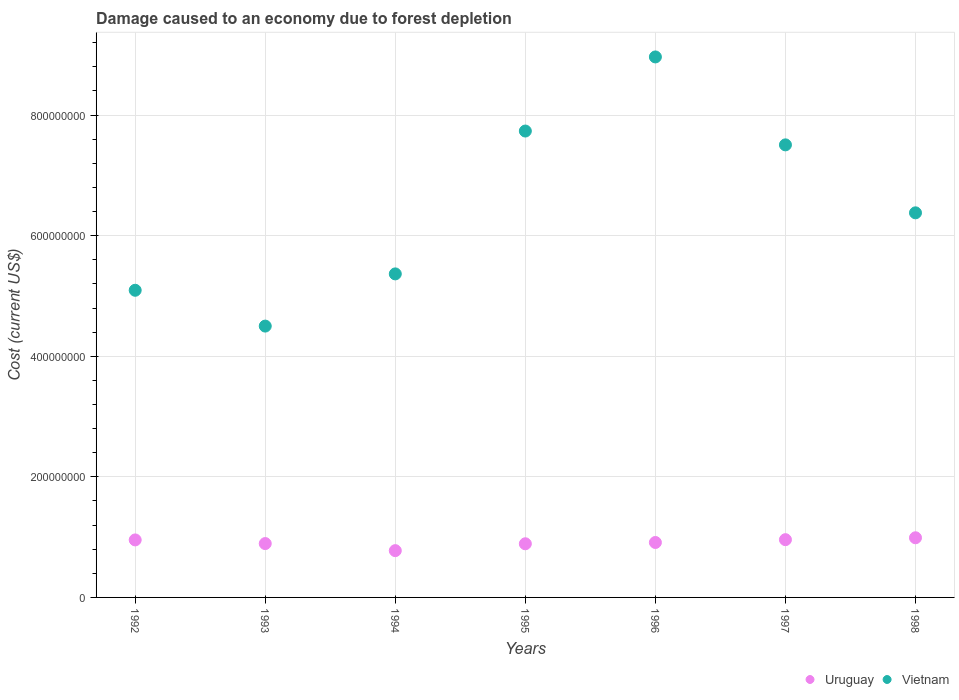How many different coloured dotlines are there?
Keep it short and to the point. 2. Is the number of dotlines equal to the number of legend labels?
Keep it short and to the point. Yes. What is the cost of damage caused due to forest depletion in Vietnam in 1996?
Give a very brief answer. 8.96e+08. Across all years, what is the maximum cost of damage caused due to forest depletion in Uruguay?
Give a very brief answer. 9.89e+07. Across all years, what is the minimum cost of damage caused due to forest depletion in Uruguay?
Your answer should be very brief. 7.76e+07. In which year was the cost of damage caused due to forest depletion in Vietnam maximum?
Ensure brevity in your answer.  1996. What is the total cost of damage caused due to forest depletion in Vietnam in the graph?
Offer a very short reply. 4.55e+09. What is the difference between the cost of damage caused due to forest depletion in Uruguay in 1993 and that in 1996?
Give a very brief answer. -1.80e+06. What is the difference between the cost of damage caused due to forest depletion in Vietnam in 1992 and the cost of damage caused due to forest depletion in Uruguay in 1995?
Give a very brief answer. 4.20e+08. What is the average cost of damage caused due to forest depletion in Vietnam per year?
Your answer should be very brief. 6.51e+08. In the year 1995, what is the difference between the cost of damage caused due to forest depletion in Uruguay and cost of damage caused due to forest depletion in Vietnam?
Provide a succinct answer. -6.85e+08. What is the ratio of the cost of damage caused due to forest depletion in Uruguay in 1992 to that in 1996?
Ensure brevity in your answer.  1.05. Is the cost of damage caused due to forest depletion in Vietnam in 1994 less than that in 1998?
Keep it short and to the point. Yes. Is the difference between the cost of damage caused due to forest depletion in Uruguay in 1993 and 1998 greater than the difference between the cost of damage caused due to forest depletion in Vietnam in 1993 and 1998?
Provide a succinct answer. Yes. What is the difference between the highest and the second highest cost of damage caused due to forest depletion in Vietnam?
Provide a succinct answer. 1.23e+08. What is the difference between the highest and the lowest cost of damage caused due to forest depletion in Uruguay?
Keep it short and to the point. 2.13e+07. Is the sum of the cost of damage caused due to forest depletion in Uruguay in 1995 and 1996 greater than the maximum cost of damage caused due to forest depletion in Vietnam across all years?
Make the answer very short. No. How many years are there in the graph?
Keep it short and to the point. 7. What is the difference between two consecutive major ticks on the Y-axis?
Offer a terse response. 2.00e+08. How are the legend labels stacked?
Your answer should be very brief. Horizontal. What is the title of the graph?
Your answer should be compact. Damage caused to an economy due to forest depletion. What is the label or title of the Y-axis?
Ensure brevity in your answer.  Cost (current US$). What is the Cost (current US$) of Uruguay in 1992?
Offer a very short reply. 9.54e+07. What is the Cost (current US$) in Vietnam in 1992?
Give a very brief answer. 5.09e+08. What is the Cost (current US$) of Uruguay in 1993?
Keep it short and to the point. 8.93e+07. What is the Cost (current US$) of Vietnam in 1993?
Your answer should be very brief. 4.50e+08. What is the Cost (current US$) in Uruguay in 1994?
Offer a very short reply. 7.76e+07. What is the Cost (current US$) in Vietnam in 1994?
Ensure brevity in your answer.  5.37e+08. What is the Cost (current US$) of Uruguay in 1995?
Offer a very short reply. 8.90e+07. What is the Cost (current US$) in Vietnam in 1995?
Provide a short and direct response. 7.74e+08. What is the Cost (current US$) in Uruguay in 1996?
Ensure brevity in your answer.  9.11e+07. What is the Cost (current US$) in Vietnam in 1996?
Ensure brevity in your answer.  8.96e+08. What is the Cost (current US$) of Uruguay in 1997?
Ensure brevity in your answer.  9.58e+07. What is the Cost (current US$) of Vietnam in 1997?
Ensure brevity in your answer.  7.51e+08. What is the Cost (current US$) of Uruguay in 1998?
Ensure brevity in your answer.  9.89e+07. What is the Cost (current US$) in Vietnam in 1998?
Make the answer very short. 6.38e+08. Across all years, what is the maximum Cost (current US$) of Uruguay?
Ensure brevity in your answer.  9.89e+07. Across all years, what is the maximum Cost (current US$) in Vietnam?
Provide a short and direct response. 8.96e+08. Across all years, what is the minimum Cost (current US$) in Uruguay?
Your answer should be very brief. 7.76e+07. Across all years, what is the minimum Cost (current US$) in Vietnam?
Your answer should be very brief. 4.50e+08. What is the total Cost (current US$) in Uruguay in the graph?
Give a very brief answer. 6.37e+08. What is the total Cost (current US$) in Vietnam in the graph?
Give a very brief answer. 4.55e+09. What is the difference between the Cost (current US$) of Uruguay in 1992 and that in 1993?
Provide a short and direct response. 6.05e+06. What is the difference between the Cost (current US$) in Vietnam in 1992 and that in 1993?
Offer a very short reply. 5.94e+07. What is the difference between the Cost (current US$) in Uruguay in 1992 and that in 1994?
Make the answer very short. 1.78e+07. What is the difference between the Cost (current US$) in Vietnam in 1992 and that in 1994?
Make the answer very short. -2.72e+07. What is the difference between the Cost (current US$) in Uruguay in 1992 and that in 1995?
Ensure brevity in your answer.  6.38e+06. What is the difference between the Cost (current US$) in Vietnam in 1992 and that in 1995?
Your answer should be very brief. -2.64e+08. What is the difference between the Cost (current US$) of Uruguay in 1992 and that in 1996?
Your answer should be very brief. 4.25e+06. What is the difference between the Cost (current US$) in Vietnam in 1992 and that in 1996?
Offer a very short reply. -3.87e+08. What is the difference between the Cost (current US$) of Uruguay in 1992 and that in 1997?
Provide a short and direct response. -4.16e+05. What is the difference between the Cost (current US$) of Vietnam in 1992 and that in 1997?
Make the answer very short. -2.41e+08. What is the difference between the Cost (current US$) of Uruguay in 1992 and that in 1998?
Provide a short and direct response. -3.57e+06. What is the difference between the Cost (current US$) in Vietnam in 1992 and that in 1998?
Your answer should be very brief. -1.28e+08. What is the difference between the Cost (current US$) of Uruguay in 1993 and that in 1994?
Provide a short and direct response. 1.17e+07. What is the difference between the Cost (current US$) of Vietnam in 1993 and that in 1994?
Ensure brevity in your answer.  -8.66e+07. What is the difference between the Cost (current US$) of Uruguay in 1993 and that in 1995?
Provide a succinct answer. 3.34e+05. What is the difference between the Cost (current US$) of Vietnam in 1993 and that in 1995?
Provide a short and direct response. -3.23e+08. What is the difference between the Cost (current US$) of Uruguay in 1993 and that in 1996?
Ensure brevity in your answer.  -1.80e+06. What is the difference between the Cost (current US$) of Vietnam in 1993 and that in 1996?
Your answer should be very brief. -4.46e+08. What is the difference between the Cost (current US$) of Uruguay in 1993 and that in 1997?
Provide a short and direct response. -6.47e+06. What is the difference between the Cost (current US$) of Vietnam in 1993 and that in 1997?
Offer a very short reply. -3.01e+08. What is the difference between the Cost (current US$) of Uruguay in 1993 and that in 1998?
Make the answer very short. -9.62e+06. What is the difference between the Cost (current US$) in Vietnam in 1993 and that in 1998?
Provide a short and direct response. -1.88e+08. What is the difference between the Cost (current US$) of Uruguay in 1994 and that in 1995?
Your response must be concise. -1.14e+07. What is the difference between the Cost (current US$) in Vietnam in 1994 and that in 1995?
Provide a short and direct response. -2.37e+08. What is the difference between the Cost (current US$) in Uruguay in 1994 and that in 1996?
Your answer should be compact. -1.35e+07. What is the difference between the Cost (current US$) in Vietnam in 1994 and that in 1996?
Offer a very short reply. -3.60e+08. What is the difference between the Cost (current US$) in Uruguay in 1994 and that in 1997?
Your response must be concise. -1.82e+07. What is the difference between the Cost (current US$) of Vietnam in 1994 and that in 1997?
Provide a succinct answer. -2.14e+08. What is the difference between the Cost (current US$) in Uruguay in 1994 and that in 1998?
Provide a short and direct response. -2.13e+07. What is the difference between the Cost (current US$) in Vietnam in 1994 and that in 1998?
Your answer should be compact. -1.01e+08. What is the difference between the Cost (current US$) in Uruguay in 1995 and that in 1996?
Your response must be concise. -2.14e+06. What is the difference between the Cost (current US$) in Vietnam in 1995 and that in 1996?
Keep it short and to the point. -1.23e+08. What is the difference between the Cost (current US$) of Uruguay in 1995 and that in 1997?
Your answer should be very brief. -6.80e+06. What is the difference between the Cost (current US$) in Vietnam in 1995 and that in 1997?
Your response must be concise. 2.29e+07. What is the difference between the Cost (current US$) of Uruguay in 1995 and that in 1998?
Provide a succinct answer. -9.95e+06. What is the difference between the Cost (current US$) of Vietnam in 1995 and that in 1998?
Ensure brevity in your answer.  1.36e+08. What is the difference between the Cost (current US$) in Uruguay in 1996 and that in 1997?
Make the answer very short. -4.66e+06. What is the difference between the Cost (current US$) in Vietnam in 1996 and that in 1997?
Your response must be concise. 1.46e+08. What is the difference between the Cost (current US$) of Uruguay in 1996 and that in 1998?
Your response must be concise. -7.82e+06. What is the difference between the Cost (current US$) in Vietnam in 1996 and that in 1998?
Your response must be concise. 2.59e+08. What is the difference between the Cost (current US$) in Uruguay in 1997 and that in 1998?
Your answer should be very brief. -3.15e+06. What is the difference between the Cost (current US$) in Vietnam in 1997 and that in 1998?
Your answer should be very brief. 1.13e+08. What is the difference between the Cost (current US$) in Uruguay in 1992 and the Cost (current US$) in Vietnam in 1993?
Offer a terse response. -3.55e+08. What is the difference between the Cost (current US$) of Uruguay in 1992 and the Cost (current US$) of Vietnam in 1994?
Ensure brevity in your answer.  -4.41e+08. What is the difference between the Cost (current US$) of Uruguay in 1992 and the Cost (current US$) of Vietnam in 1995?
Offer a very short reply. -6.78e+08. What is the difference between the Cost (current US$) in Uruguay in 1992 and the Cost (current US$) in Vietnam in 1996?
Give a very brief answer. -8.01e+08. What is the difference between the Cost (current US$) in Uruguay in 1992 and the Cost (current US$) in Vietnam in 1997?
Your response must be concise. -6.55e+08. What is the difference between the Cost (current US$) of Uruguay in 1992 and the Cost (current US$) of Vietnam in 1998?
Make the answer very short. -5.42e+08. What is the difference between the Cost (current US$) in Uruguay in 1993 and the Cost (current US$) in Vietnam in 1994?
Offer a terse response. -4.47e+08. What is the difference between the Cost (current US$) of Uruguay in 1993 and the Cost (current US$) of Vietnam in 1995?
Make the answer very short. -6.84e+08. What is the difference between the Cost (current US$) of Uruguay in 1993 and the Cost (current US$) of Vietnam in 1996?
Give a very brief answer. -8.07e+08. What is the difference between the Cost (current US$) of Uruguay in 1993 and the Cost (current US$) of Vietnam in 1997?
Provide a short and direct response. -6.61e+08. What is the difference between the Cost (current US$) of Uruguay in 1993 and the Cost (current US$) of Vietnam in 1998?
Your answer should be compact. -5.49e+08. What is the difference between the Cost (current US$) in Uruguay in 1994 and the Cost (current US$) in Vietnam in 1995?
Your response must be concise. -6.96e+08. What is the difference between the Cost (current US$) in Uruguay in 1994 and the Cost (current US$) in Vietnam in 1996?
Ensure brevity in your answer.  -8.19e+08. What is the difference between the Cost (current US$) of Uruguay in 1994 and the Cost (current US$) of Vietnam in 1997?
Keep it short and to the point. -6.73e+08. What is the difference between the Cost (current US$) in Uruguay in 1994 and the Cost (current US$) in Vietnam in 1998?
Keep it short and to the point. -5.60e+08. What is the difference between the Cost (current US$) of Uruguay in 1995 and the Cost (current US$) of Vietnam in 1996?
Your answer should be compact. -8.07e+08. What is the difference between the Cost (current US$) in Uruguay in 1995 and the Cost (current US$) in Vietnam in 1997?
Provide a short and direct response. -6.62e+08. What is the difference between the Cost (current US$) in Uruguay in 1995 and the Cost (current US$) in Vietnam in 1998?
Keep it short and to the point. -5.49e+08. What is the difference between the Cost (current US$) of Uruguay in 1996 and the Cost (current US$) of Vietnam in 1997?
Give a very brief answer. -6.59e+08. What is the difference between the Cost (current US$) in Uruguay in 1996 and the Cost (current US$) in Vietnam in 1998?
Provide a short and direct response. -5.47e+08. What is the difference between the Cost (current US$) of Uruguay in 1997 and the Cost (current US$) of Vietnam in 1998?
Make the answer very short. -5.42e+08. What is the average Cost (current US$) in Uruguay per year?
Offer a terse response. 9.10e+07. What is the average Cost (current US$) of Vietnam per year?
Your answer should be very brief. 6.51e+08. In the year 1992, what is the difference between the Cost (current US$) in Uruguay and Cost (current US$) in Vietnam?
Provide a succinct answer. -4.14e+08. In the year 1993, what is the difference between the Cost (current US$) of Uruguay and Cost (current US$) of Vietnam?
Keep it short and to the point. -3.61e+08. In the year 1994, what is the difference between the Cost (current US$) of Uruguay and Cost (current US$) of Vietnam?
Provide a short and direct response. -4.59e+08. In the year 1995, what is the difference between the Cost (current US$) of Uruguay and Cost (current US$) of Vietnam?
Your answer should be compact. -6.85e+08. In the year 1996, what is the difference between the Cost (current US$) in Uruguay and Cost (current US$) in Vietnam?
Provide a succinct answer. -8.05e+08. In the year 1997, what is the difference between the Cost (current US$) of Uruguay and Cost (current US$) of Vietnam?
Give a very brief answer. -6.55e+08. In the year 1998, what is the difference between the Cost (current US$) of Uruguay and Cost (current US$) of Vietnam?
Make the answer very short. -5.39e+08. What is the ratio of the Cost (current US$) of Uruguay in 1992 to that in 1993?
Keep it short and to the point. 1.07. What is the ratio of the Cost (current US$) of Vietnam in 1992 to that in 1993?
Offer a terse response. 1.13. What is the ratio of the Cost (current US$) of Uruguay in 1992 to that in 1994?
Your answer should be very brief. 1.23. What is the ratio of the Cost (current US$) of Vietnam in 1992 to that in 1994?
Make the answer very short. 0.95. What is the ratio of the Cost (current US$) of Uruguay in 1992 to that in 1995?
Provide a short and direct response. 1.07. What is the ratio of the Cost (current US$) of Vietnam in 1992 to that in 1995?
Ensure brevity in your answer.  0.66. What is the ratio of the Cost (current US$) of Uruguay in 1992 to that in 1996?
Your answer should be compact. 1.05. What is the ratio of the Cost (current US$) of Vietnam in 1992 to that in 1996?
Make the answer very short. 0.57. What is the ratio of the Cost (current US$) of Uruguay in 1992 to that in 1997?
Ensure brevity in your answer.  1. What is the ratio of the Cost (current US$) in Vietnam in 1992 to that in 1997?
Offer a very short reply. 0.68. What is the ratio of the Cost (current US$) in Uruguay in 1992 to that in 1998?
Offer a very short reply. 0.96. What is the ratio of the Cost (current US$) in Vietnam in 1992 to that in 1998?
Offer a terse response. 0.8. What is the ratio of the Cost (current US$) of Uruguay in 1993 to that in 1994?
Your response must be concise. 1.15. What is the ratio of the Cost (current US$) in Vietnam in 1993 to that in 1994?
Keep it short and to the point. 0.84. What is the ratio of the Cost (current US$) of Vietnam in 1993 to that in 1995?
Offer a very short reply. 0.58. What is the ratio of the Cost (current US$) of Uruguay in 1993 to that in 1996?
Give a very brief answer. 0.98. What is the ratio of the Cost (current US$) of Vietnam in 1993 to that in 1996?
Your response must be concise. 0.5. What is the ratio of the Cost (current US$) in Uruguay in 1993 to that in 1997?
Your answer should be compact. 0.93. What is the ratio of the Cost (current US$) of Vietnam in 1993 to that in 1997?
Make the answer very short. 0.6. What is the ratio of the Cost (current US$) in Uruguay in 1993 to that in 1998?
Give a very brief answer. 0.9. What is the ratio of the Cost (current US$) in Vietnam in 1993 to that in 1998?
Your answer should be compact. 0.71. What is the ratio of the Cost (current US$) in Uruguay in 1994 to that in 1995?
Your answer should be very brief. 0.87. What is the ratio of the Cost (current US$) in Vietnam in 1994 to that in 1995?
Provide a short and direct response. 0.69. What is the ratio of the Cost (current US$) of Uruguay in 1994 to that in 1996?
Make the answer very short. 0.85. What is the ratio of the Cost (current US$) in Vietnam in 1994 to that in 1996?
Your answer should be very brief. 0.6. What is the ratio of the Cost (current US$) in Uruguay in 1994 to that in 1997?
Give a very brief answer. 0.81. What is the ratio of the Cost (current US$) in Vietnam in 1994 to that in 1997?
Your answer should be compact. 0.71. What is the ratio of the Cost (current US$) of Uruguay in 1994 to that in 1998?
Your answer should be compact. 0.78. What is the ratio of the Cost (current US$) of Vietnam in 1994 to that in 1998?
Provide a succinct answer. 0.84. What is the ratio of the Cost (current US$) of Uruguay in 1995 to that in 1996?
Keep it short and to the point. 0.98. What is the ratio of the Cost (current US$) of Vietnam in 1995 to that in 1996?
Offer a terse response. 0.86. What is the ratio of the Cost (current US$) in Uruguay in 1995 to that in 1997?
Your response must be concise. 0.93. What is the ratio of the Cost (current US$) in Vietnam in 1995 to that in 1997?
Give a very brief answer. 1.03. What is the ratio of the Cost (current US$) of Uruguay in 1995 to that in 1998?
Provide a short and direct response. 0.9. What is the ratio of the Cost (current US$) in Vietnam in 1995 to that in 1998?
Offer a terse response. 1.21. What is the ratio of the Cost (current US$) in Uruguay in 1996 to that in 1997?
Your response must be concise. 0.95. What is the ratio of the Cost (current US$) of Vietnam in 1996 to that in 1997?
Offer a very short reply. 1.19. What is the ratio of the Cost (current US$) in Uruguay in 1996 to that in 1998?
Provide a succinct answer. 0.92. What is the ratio of the Cost (current US$) in Vietnam in 1996 to that in 1998?
Your answer should be very brief. 1.41. What is the ratio of the Cost (current US$) in Uruguay in 1997 to that in 1998?
Your answer should be very brief. 0.97. What is the ratio of the Cost (current US$) of Vietnam in 1997 to that in 1998?
Your answer should be very brief. 1.18. What is the difference between the highest and the second highest Cost (current US$) in Uruguay?
Your answer should be very brief. 3.15e+06. What is the difference between the highest and the second highest Cost (current US$) in Vietnam?
Make the answer very short. 1.23e+08. What is the difference between the highest and the lowest Cost (current US$) in Uruguay?
Ensure brevity in your answer.  2.13e+07. What is the difference between the highest and the lowest Cost (current US$) in Vietnam?
Provide a succinct answer. 4.46e+08. 